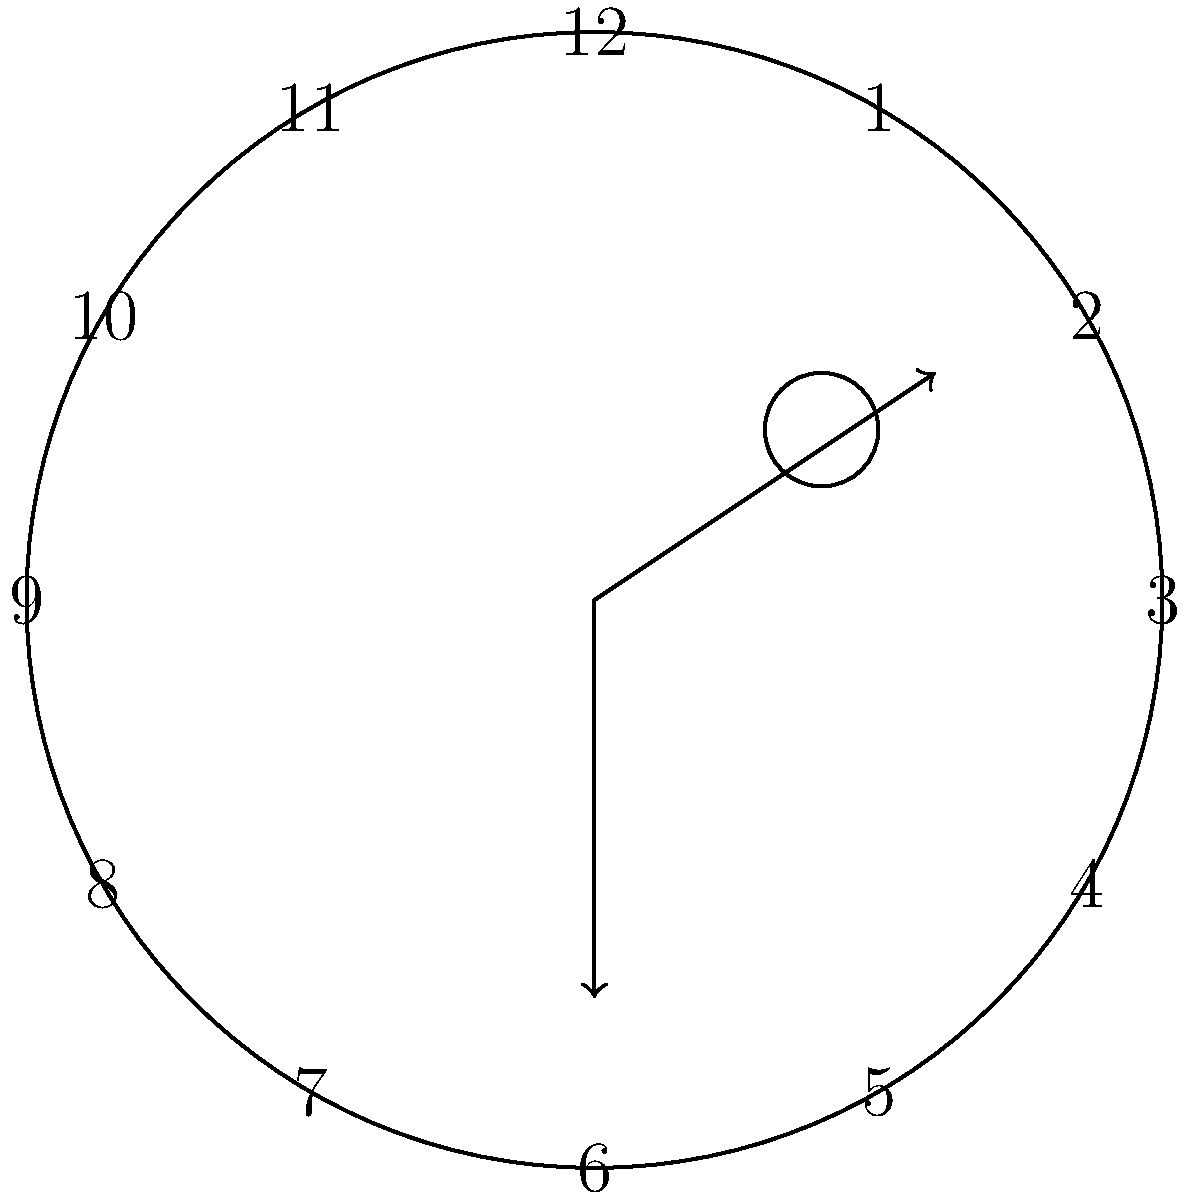As a telehealth nurse conducting a cognitive assessment for a senior patient, you're evaluating a clock drawing test. The patient was asked to draw a clock showing the time as 11:10. Based on the diagram, which cognitive domain is most likely impaired, and what specific error supports this conclusion? To evaluate the clock drawing test and identify the most likely impaired cognitive domain, let's analyze the diagram step-by-step:

1. Clock face: The circular outline is present, which is a basic spatial orientation task.

2. Number placement: The numbers 1-12 are correctly placed around the clock face, indicating preserved number sequencing and spatial organization.

3. Hand placement: This is where the main error occurs. The hands are not correctly positioned to show 11:10.
   - The longer hand (minute hand) should point to 2 for 10 minutes past the hour.
   - The shorter hand (hour hand) should be just past 11, slightly closer to 11 than 12.

4. Additional markings: There are some scribbles near the top right of the clock face, which may indicate perseveration or difficulty with task completion.

5. Cognitive domains assessed by clock drawing test:
   - Visuospatial skills
   - Executive function
   - Attention
   - Memory

Given the errors observed, the most likely impaired cognitive domain is executive function. The patient has demonstrated the ability to draw a circle and place numbers correctly (preserved visuospatial skills), but failed to correctly represent the specified time. This suggests difficulty with planning, organizing, and executing the complex task of positioning the clock hands to show a specific time.

The specific error supporting this conclusion is the incorrect placement of the clock hands. This error indicates a problem with the higher-level cognitive processes involved in translating the verbal instruction (11:10) into a visual representation, which is a key aspect of executive function.
Answer: Executive function; incorrect hand placement 